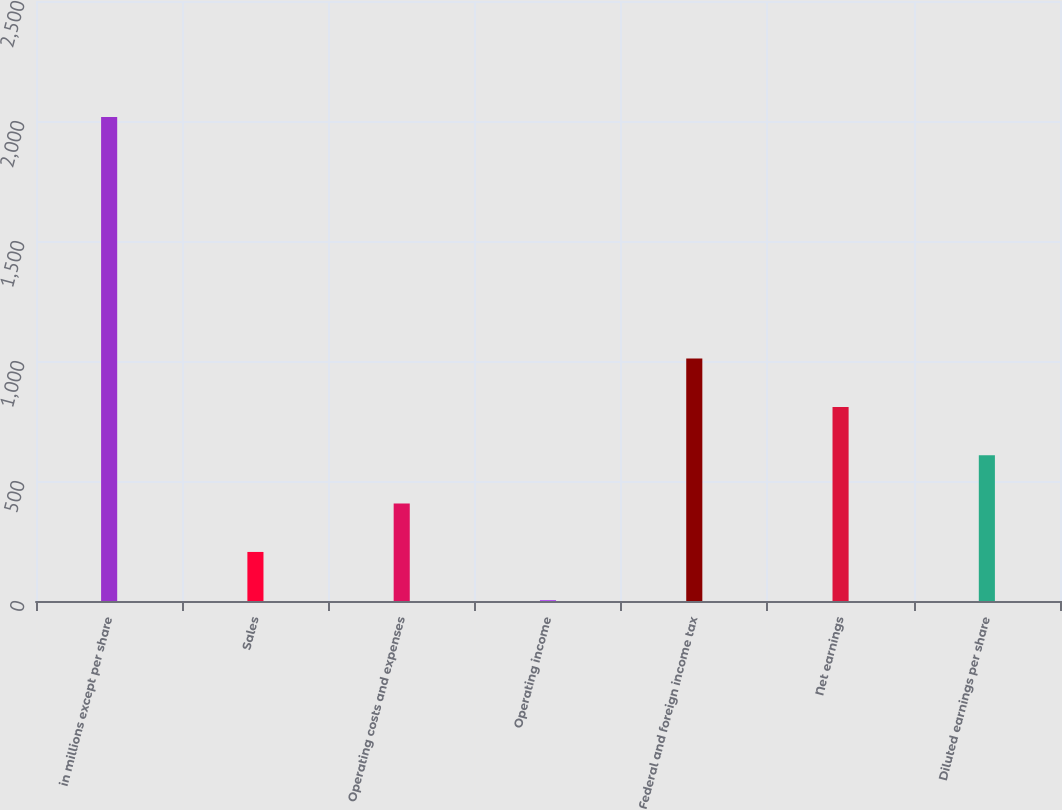Convert chart to OTSL. <chart><loc_0><loc_0><loc_500><loc_500><bar_chart><fcel>in millions except per share<fcel>Sales<fcel>Operating costs and expenses<fcel>Operating income<fcel>Federal and foreign income tax<fcel>Net earnings<fcel>Diluted earnings per share<nl><fcel>2017<fcel>204.4<fcel>405.8<fcel>3<fcel>1010<fcel>808.6<fcel>607.2<nl></chart> 